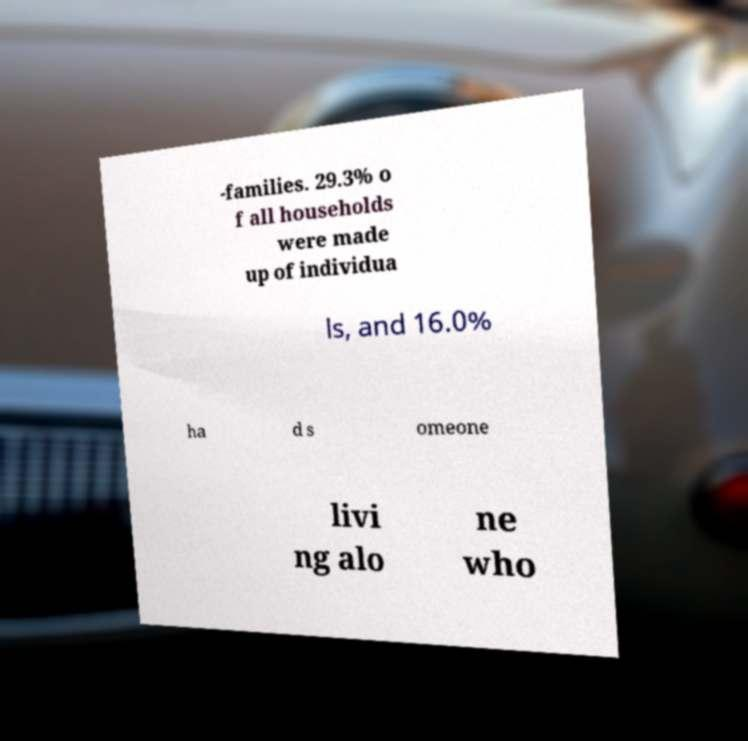For documentation purposes, I need the text within this image transcribed. Could you provide that? -families. 29.3% o f all households were made up of individua ls, and 16.0% ha d s omeone livi ng alo ne who 